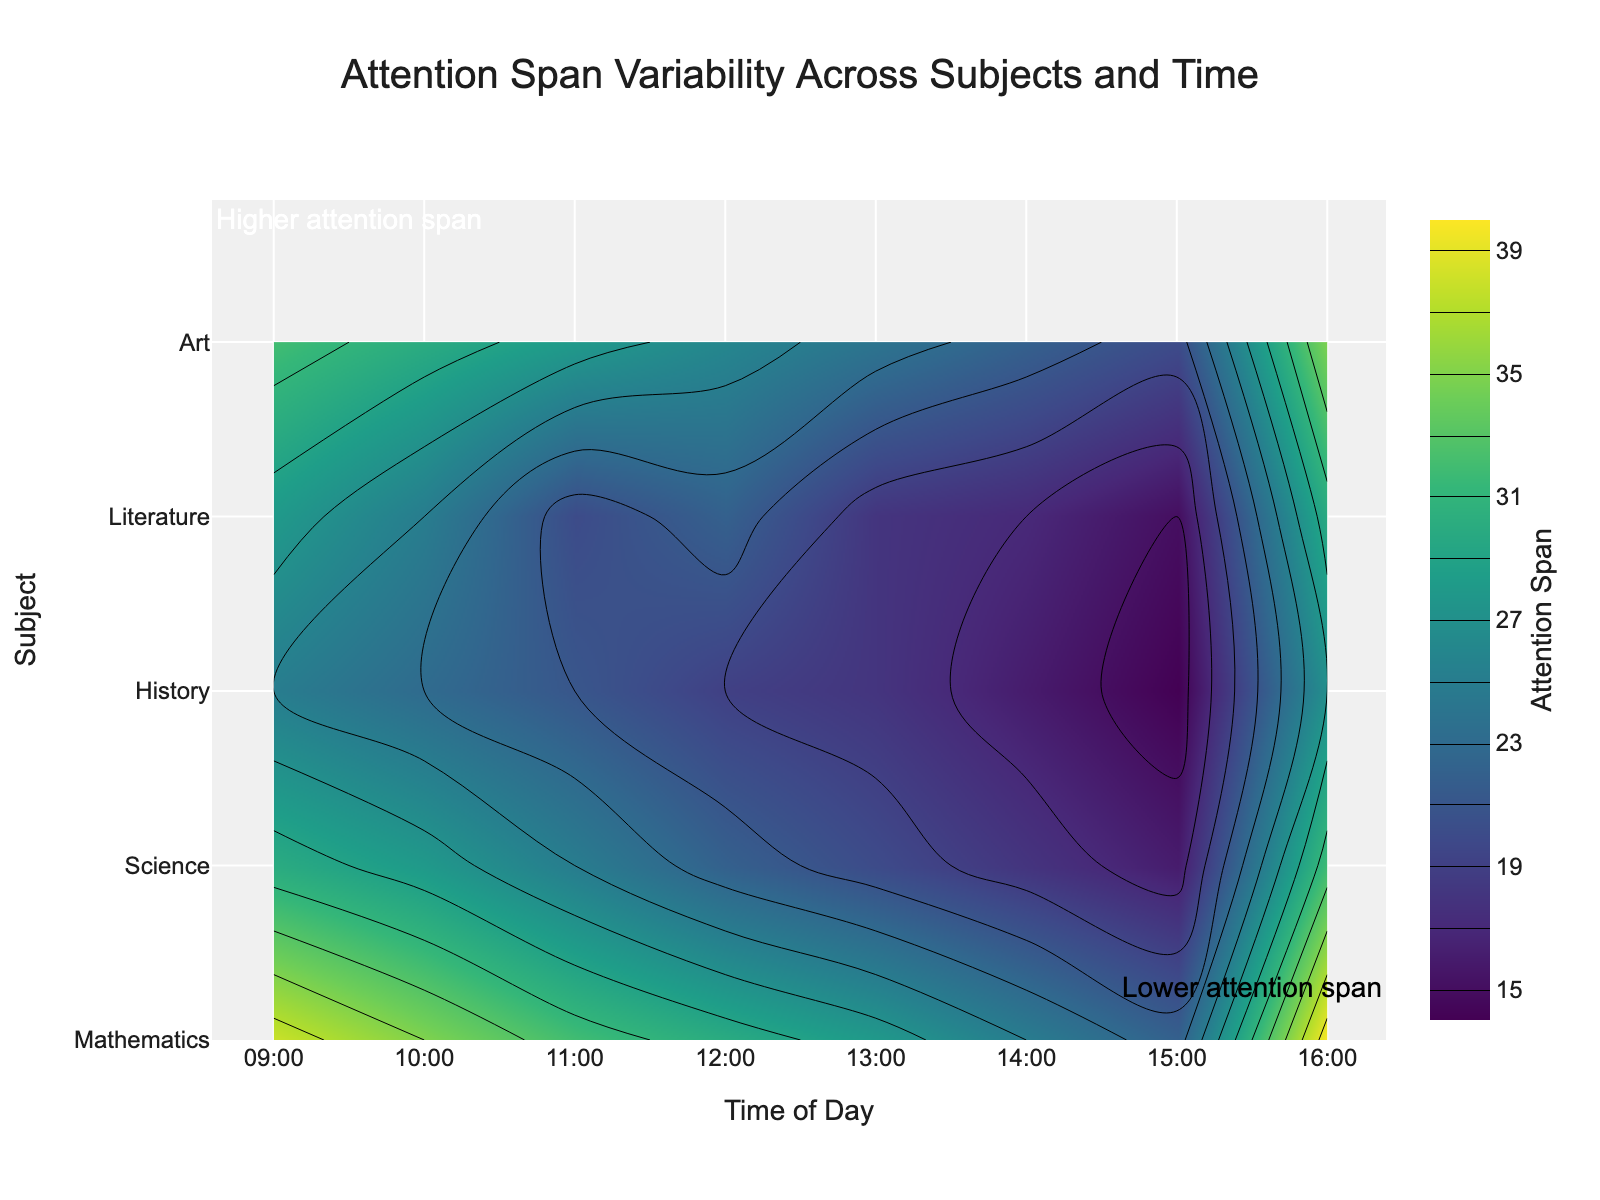What's the title of the figure? The title is typically placed at the top of the figure, often the largest text. It summarizes what the plot is about. In this case, the title reads "Attention Span Variability Across Subjects and Time”.
Answer: Attention Span Variability Across Subjects and Time What does the color gradient in the contour plot represent? On contour plots with color gradients, the legend or color bar explains what the colors represent. Here, darker colors represent lower attention spans, and lighter colors indicate higher attention spans.
Answer: Attention Span What is the attention span for Mathematics at 11:00? Locate "Mathematics" on the y-axis and trace horizontally to the 11:00 mark on the x-axis. Then, check the color associated with the contour lines. The attention span is near the value 25.
Answer: 25 Is the attention span at 12:00 generally higher for History or Science? Locate the 12:00 mark on the x-axis and compare the contour heights (color intensity) of "History" and "Science" on the y-axis. Science, with lighter shading, indicates a higher span.
Answer: Science Which subject shows the highest attention span at 9:00? Find the 9:00 mark on the x-axis and scan vertically across subjects. The lightest part of the contour will show the highest attention span. "Art" has the lightest color.
Answer: Art Compare the change in attention span from 9:00 to 16:00 for Literature and Mathematics. Which decreases more? Trace the contours from 9:00 to 16:00 for both subjects. Literature's attention span drops from 27 to 14, a decrease by 13. Mathematics falls from 30 to 15, a decrease by 15. Mathematics decreases more.
Answer: Mathematics What average attention span does Literature have across the plot's time range? Sum the attention spans of Literature from 9:00 to 16:00 and divide by the number of time points (8). (27 + 25 + 23 + 21 + 19 + 18 + 16 + 14) / 8 = 163 / 8 = 20.375.
Answer: 20.375 At what time of the day do most subjects show the lowest attention span? Observe the contour lines for all subjects across the hours on the x-axis. The darkest shading, representing the lowest spans, appears at 16:00.
Answer: 16:00 Which subject maintains the most consistent level of attention span throughout the day? Compare the contour gradients (changes in color intensity) for each subject. The one with the least color change is most consistent. History and Science both show minimal variation.
Answer: History (also acceptable: Science) Identify the subject and time with the attention span value of 22. Locate the contour line marked at 22 and trace it to the corresponding subject and time. Both Science at 13:00 and Art at 16:00 match this.
Answer: Science at 13:00 and Art at 16:00 